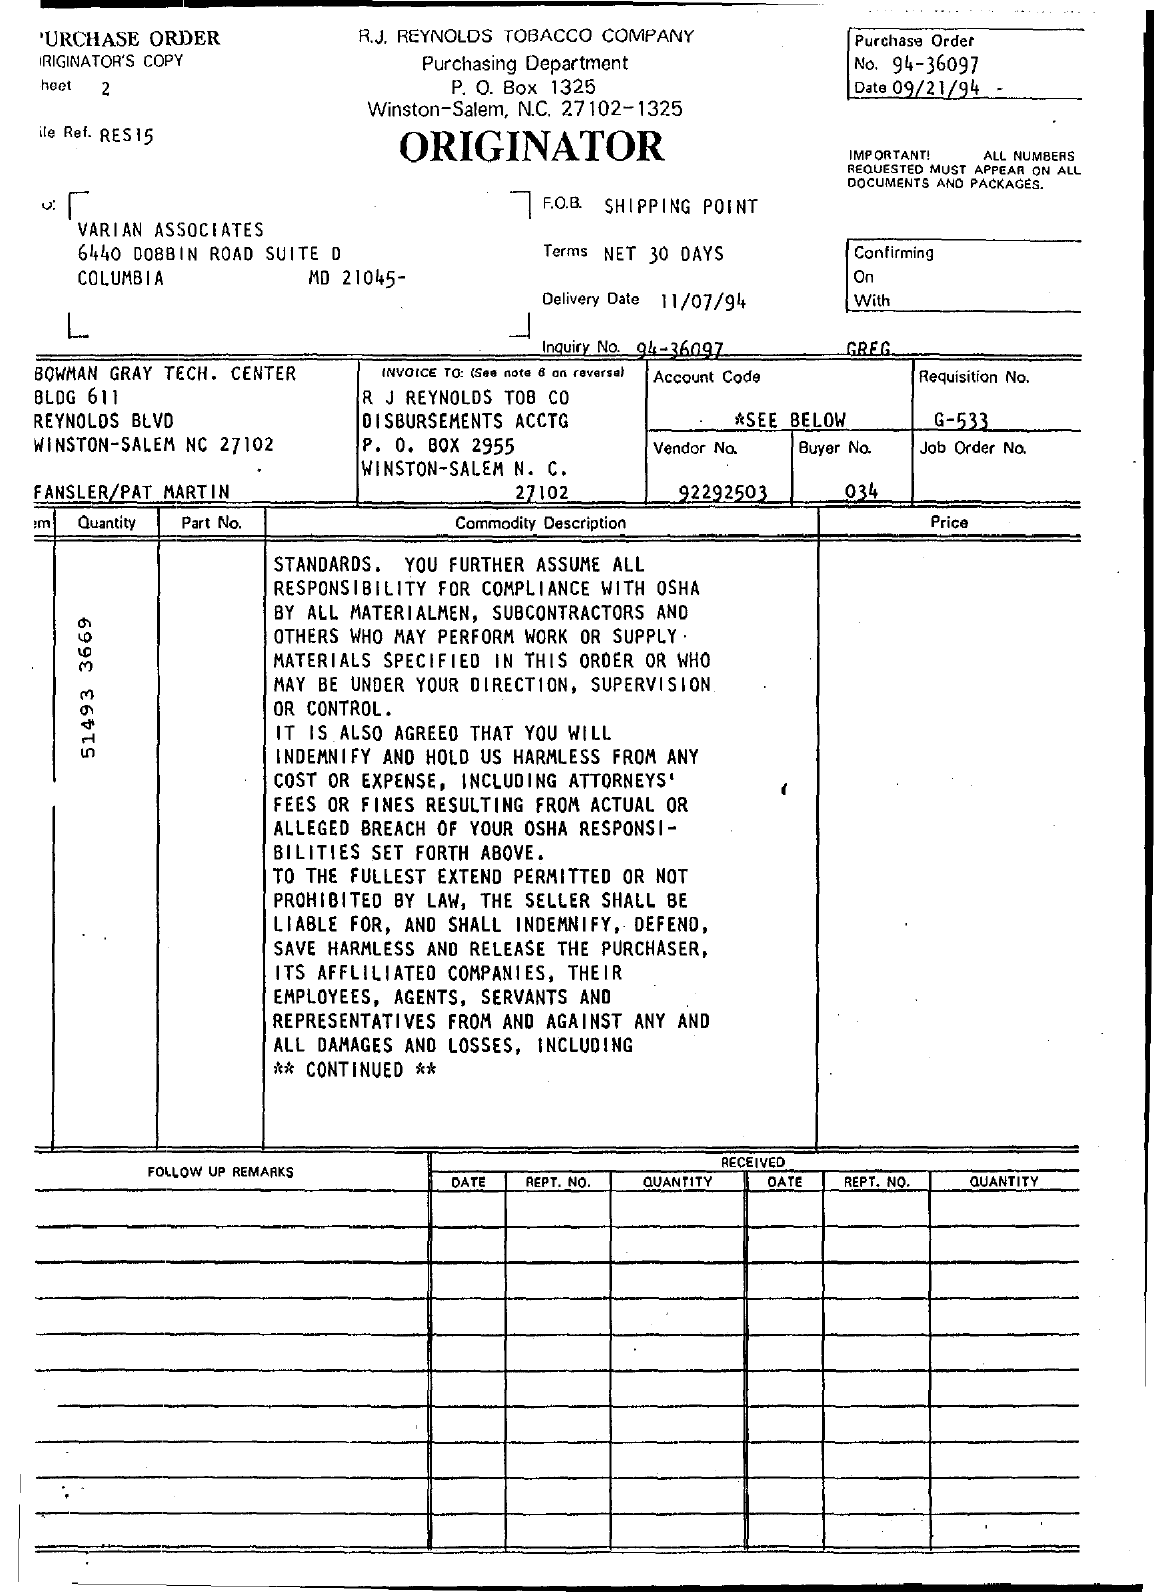What is the purchase order no.?
Your response must be concise. 94-36097. When is the purchase order date?
Provide a succinct answer. 09/21/94. When is the delivery date?
Keep it short and to the point. 11/07/94. What is the vendor number?
Ensure brevity in your answer.  92292503. What is the Requisition No.?
Offer a terse response. G-533. What is the Buyer No.?
Ensure brevity in your answer.  034. 